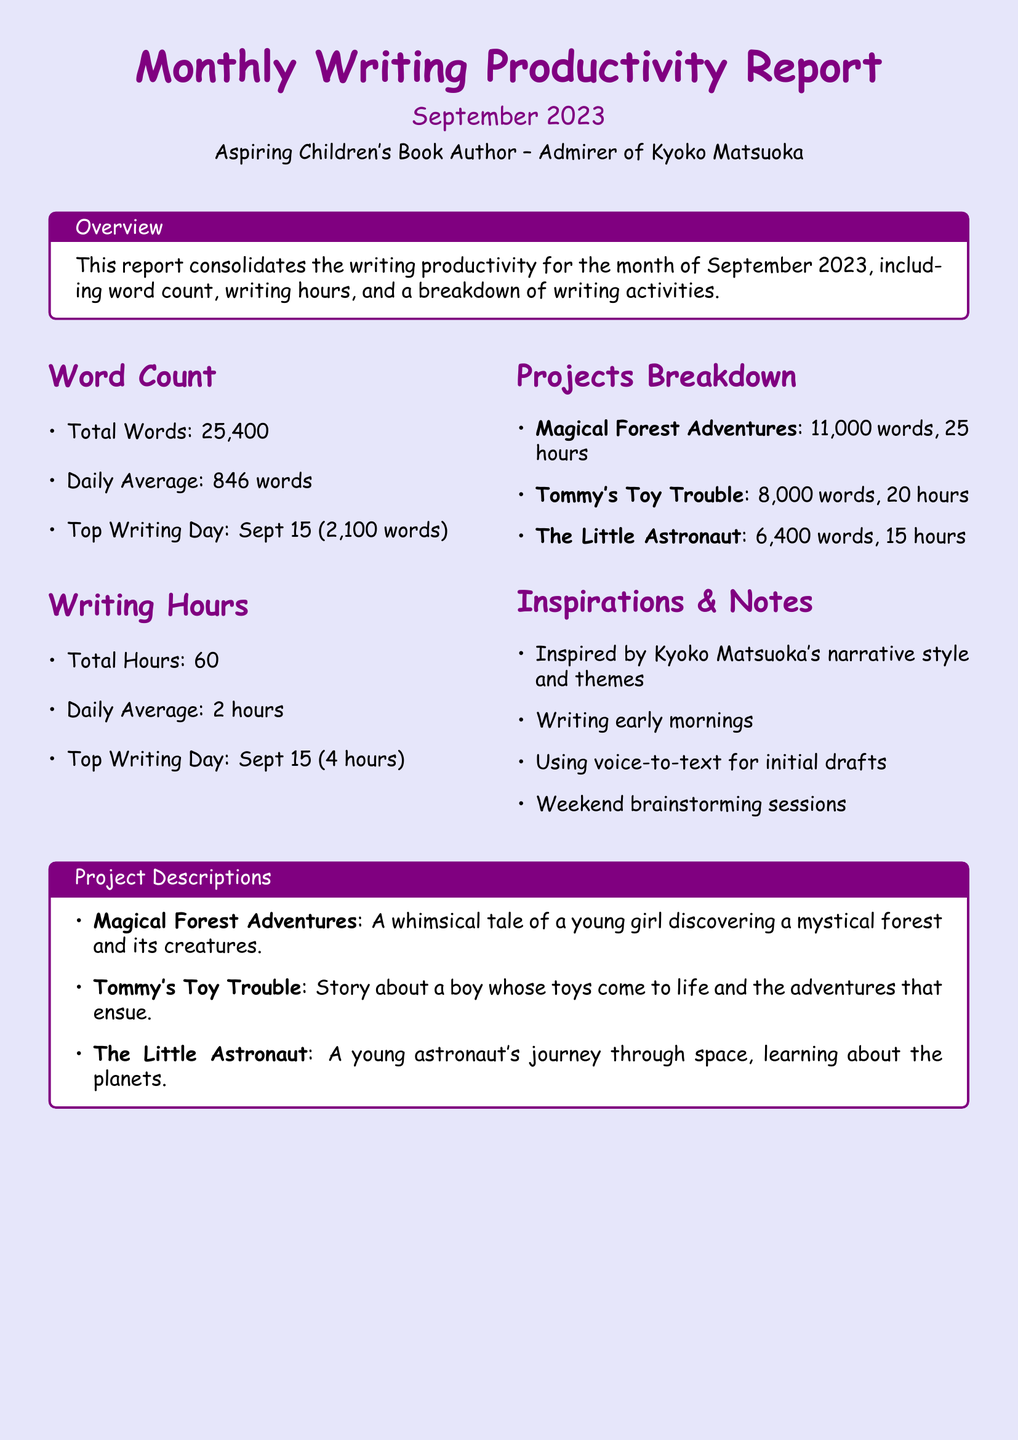What is the total word count for September 2023? The total word count is presented clearly in the Word Count section of the report.
Answer: 25,400 What was the top writing day for hours written? The top writing day for hours is highlighted in the Writing Hours section of the report.
Answer: Sept 15 (4 hours) How many projects are listed in the Projects Breakdown? The number of projects can be counted from the Projects Breakdown section.
Answer: 3 What is the daily average word count? The daily average word count is calculated based on the total words divided by the number of writing days in September.
Answer: 846 words What inspired the writing according to the report? The inspiration for writing is mentioned in the Inspirations & Notes section.
Answer: Kyoko Matsuoka's narrative style and themes What is the total writing hours recorded for September? The total writing hours is a specific figure given in the Writing Hours section.
Answer: 60 What is the word count for "Tommy's Toy Trouble"? The word count for each project is stated in the Projects Breakdown section of the report.
Answer: 8,000 words Which project had the highest total word count? The project with the highest total word count can be identified through the Projects Breakdown section.
Answer: Magical Forest Adventures What is the main theme of "The Little Astronaut"? The main theme of the project is summarized in the Project Descriptions section.
Answer: A young astronaut's journey through space 